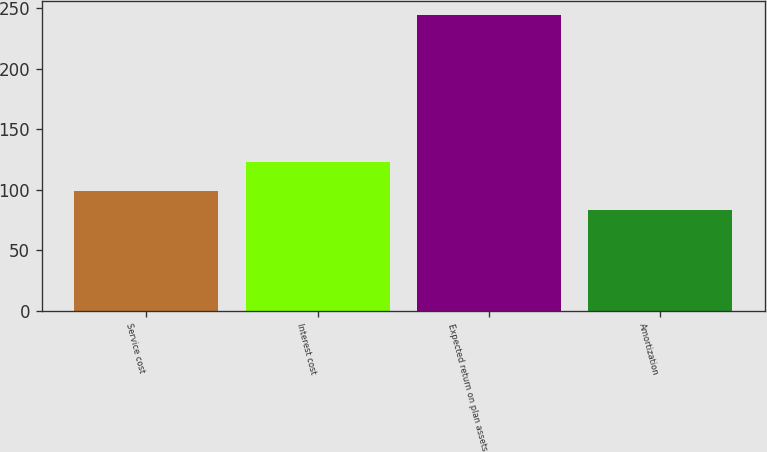Convert chart to OTSL. <chart><loc_0><loc_0><loc_500><loc_500><bar_chart><fcel>Service cost<fcel>Interest cost<fcel>Expected return on plan assets<fcel>Amortization<nl><fcel>99.1<fcel>123<fcel>244<fcel>83<nl></chart> 